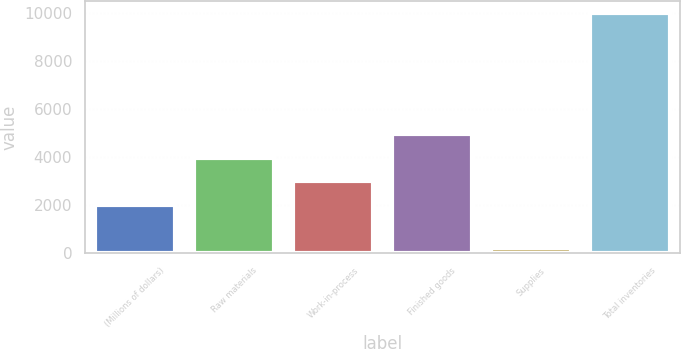Convert chart. <chart><loc_0><loc_0><loc_500><loc_500><bar_chart><fcel>(Millions of dollars)<fcel>Raw materials<fcel>Work-in-process<fcel>Finished goods<fcel>Supplies<fcel>Total inventories<nl><fcel>2017<fcel>3980.4<fcel>2998.7<fcel>4962.1<fcel>201<fcel>10018<nl></chart> 